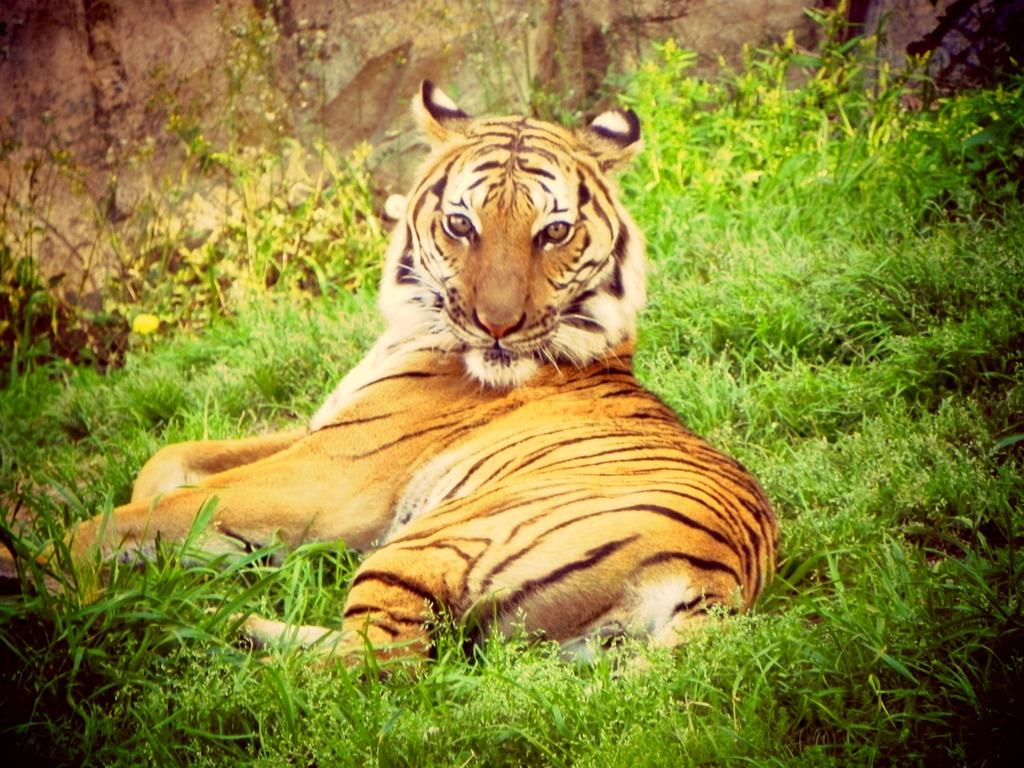What animal is in the foreground of the image? There is a tiger in the foreground of the image. What type of terrain is visible at the bottom of the image? There is grass at the bottom of the image. What type of government is depicted in the image? There is no depiction of a government in the image; it features a tiger and grass. How many twigs can be seen in the image? There are no twigs present in the image. 